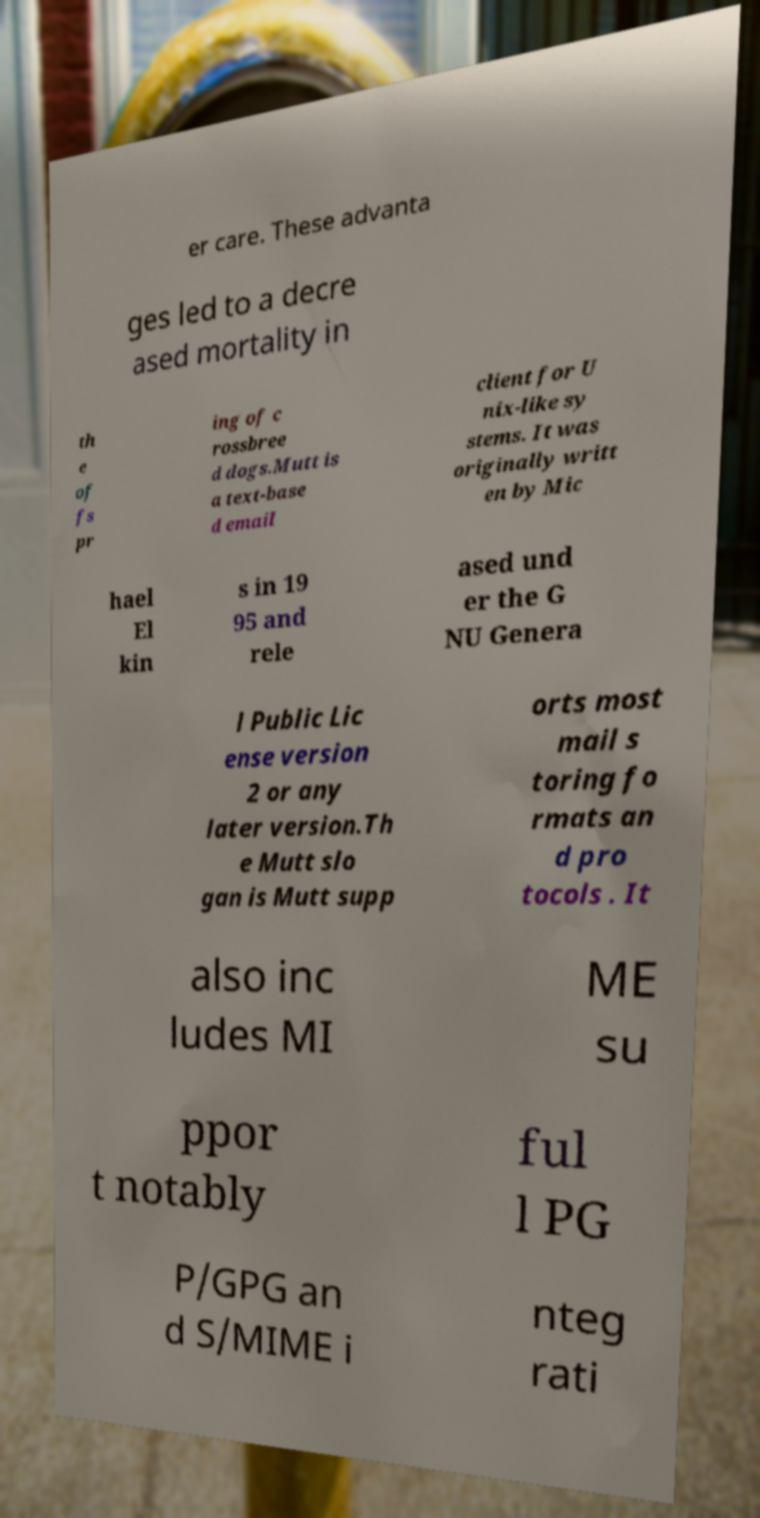I need the written content from this picture converted into text. Can you do that? er care. These advanta ges led to a decre ased mortality in th e of fs pr ing of c rossbree d dogs.Mutt is a text-base d email client for U nix-like sy stems. It was originally writt en by Mic hael El kin s in 19 95 and rele ased und er the G NU Genera l Public Lic ense version 2 or any later version.Th e Mutt slo gan is Mutt supp orts most mail s toring fo rmats an d pro tocols . It also inc ludes MI ME su ppor t notably ful l PG P/GPG an d S/MIME i nteg rati 